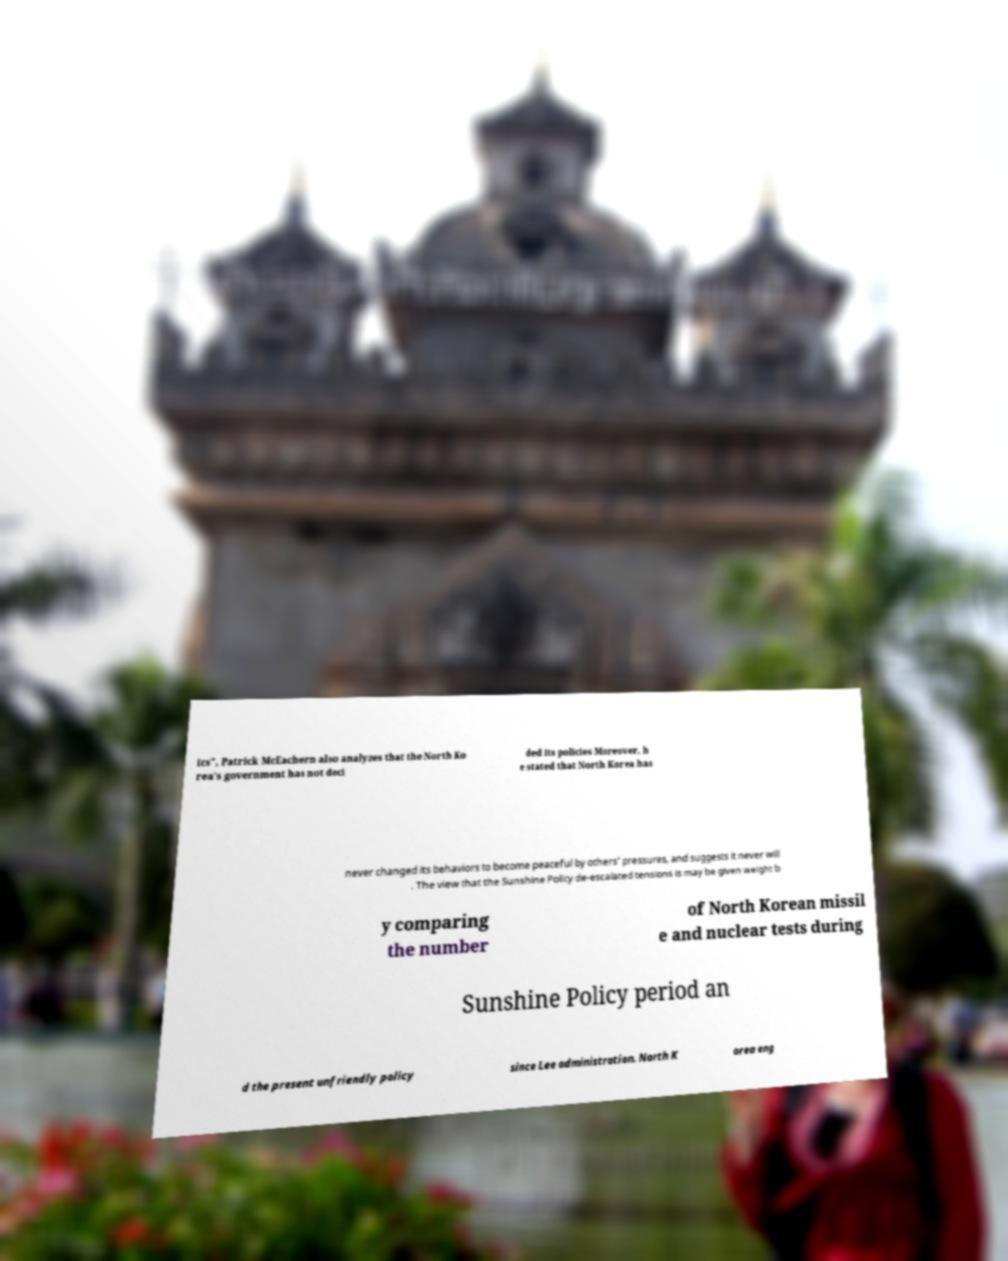Could you assist in decoding the text presented in this image and type it out clearly? ics", Patrick McEachern also analyzes that the North Ko rea's government has not deci ded its policies Moreover, h e stated that North Korea has never changed its behaviors to become peaceful by others' pressures, and suggests it never will . The view that the Sunshine Policy de-escalated tensions is may be given weight b y comparing the number of North Korean missil e and nuclear tests during Sunshine Policy period an d the present unfriendly policy since Lee administration. North K orea eng 